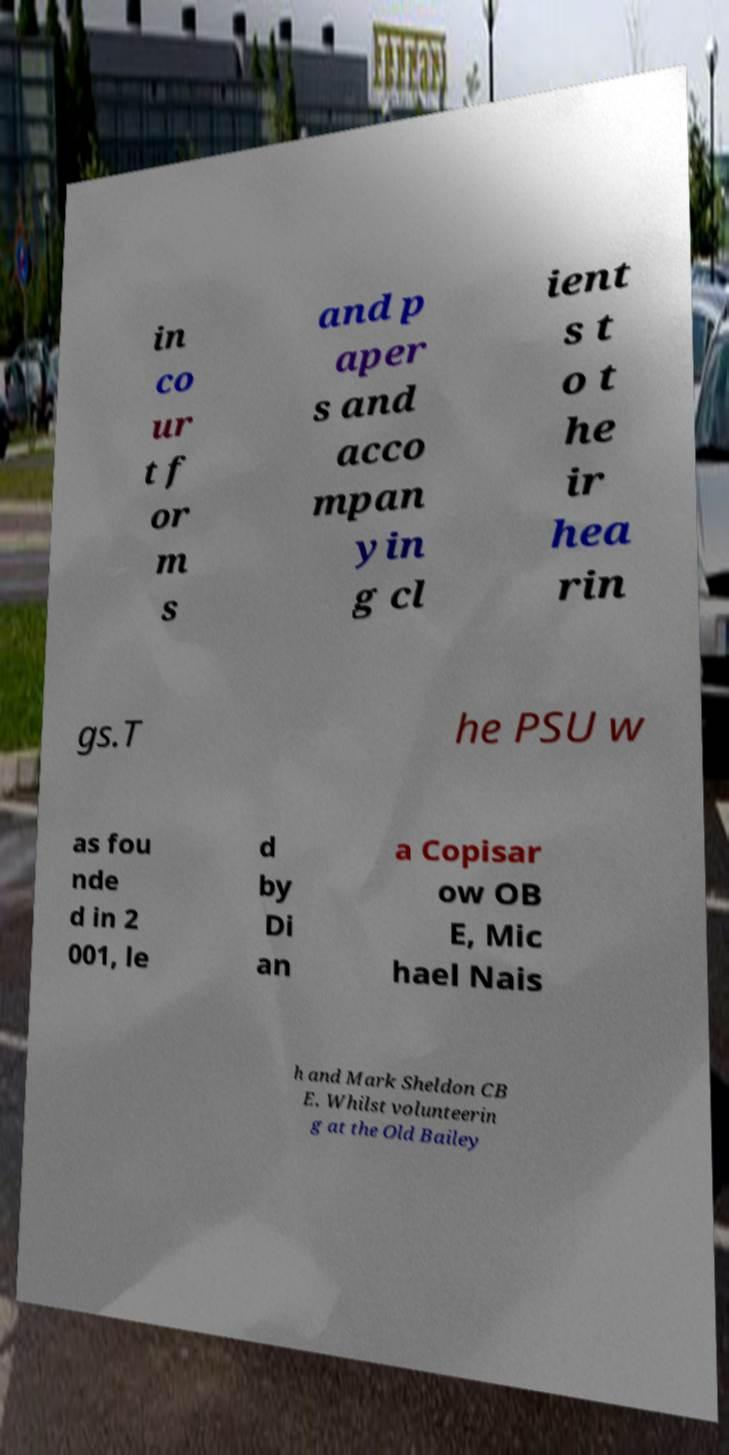Can you accurately transcribe the text from the provided image for me? in co ur t f or m s and p aper s and acco mpan yin g cl ient s t o t he ir hea rin gs.T he PSU w as fou nde d in 2 001, le d by Di an a Copisar ow OB E, Mic hael Nais h and Mark Sheldon CB E. Whilst volunteerin g at the Old Bailey 